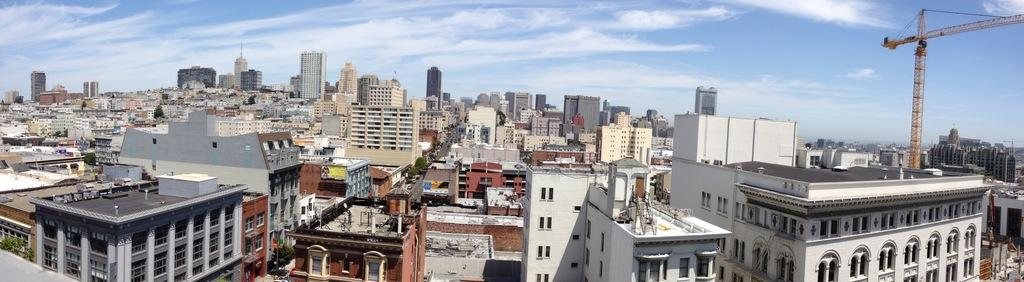What type of structures can be seen in the image? There are many buildings in the image. What part of the buildings is visible in the image? These are the windows of the buildings. What piece of construction equipment is present in the image? There is a crane in the image. What type of vegetation can be seen in the image? There are trees in the image. How would you describe the weather in the image? The sky is cloudy in the image. Where is the stage set up for the performance in the image? There is no stage present in the image; it features buildings, a crane, trees, and a cloudy sky. What type of tent can be seen in the image? There is no tent present in the image. 